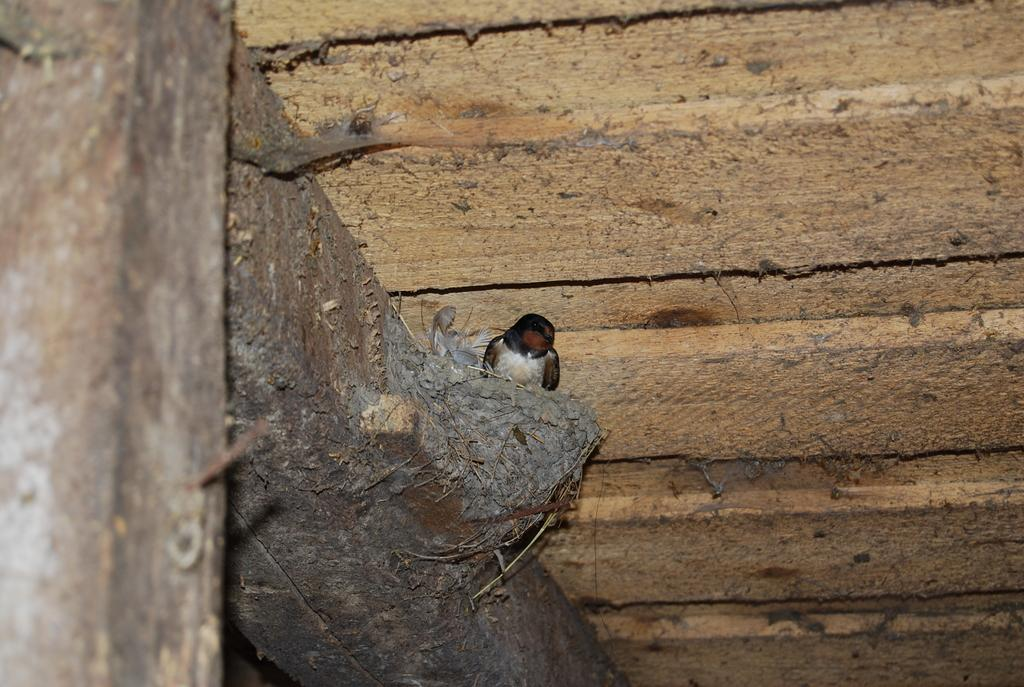What type of animal can be seen in the image? There is a bird in the image. Where is the bird located? The bird is sitting inside a nest in the image. What is the nest made of or resting on? The nest is on a wooden roof in the image. What type of scent can be detected from the fruit in the image? There is no fruit present in the image, so no scent can be detected. 